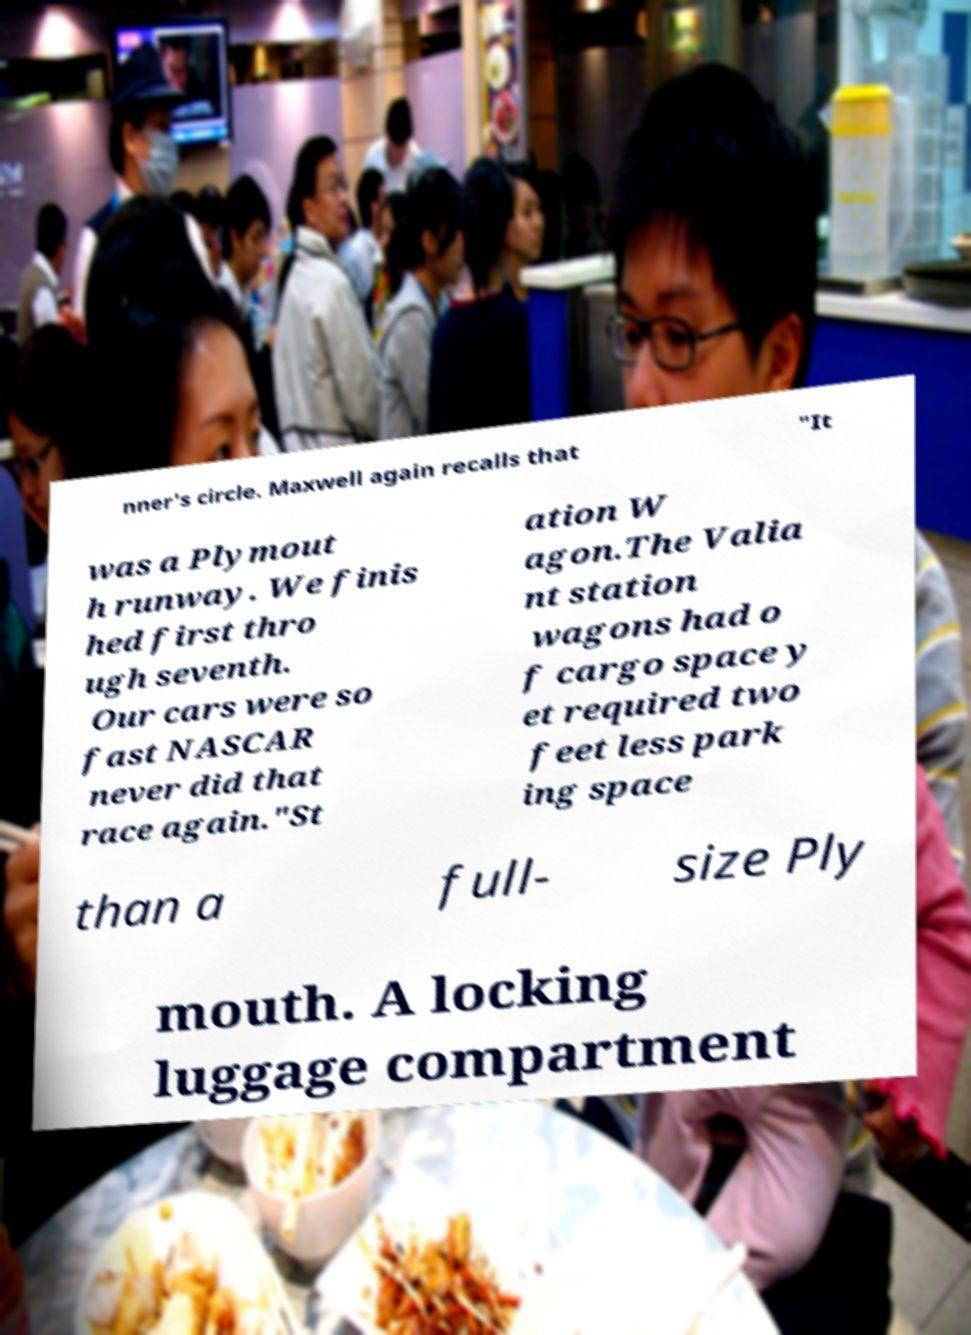Could you extract and type out the text from this image? nner's circle. Maxwell again recalls that "It was a Plymout h runway. We finis hed first thro ugh seventh. Our cars were so fast NASCAR never did that race again."St ation W agon.The Valia nt station wagons had o f cargo space y et required two feet less park ing space than a full- size Ply mouth. A locking luggage compartment 